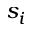Convert formula to latex. <formula><loc_0><loc_0><loc_500><loc_500>s _ { i }</formula> 